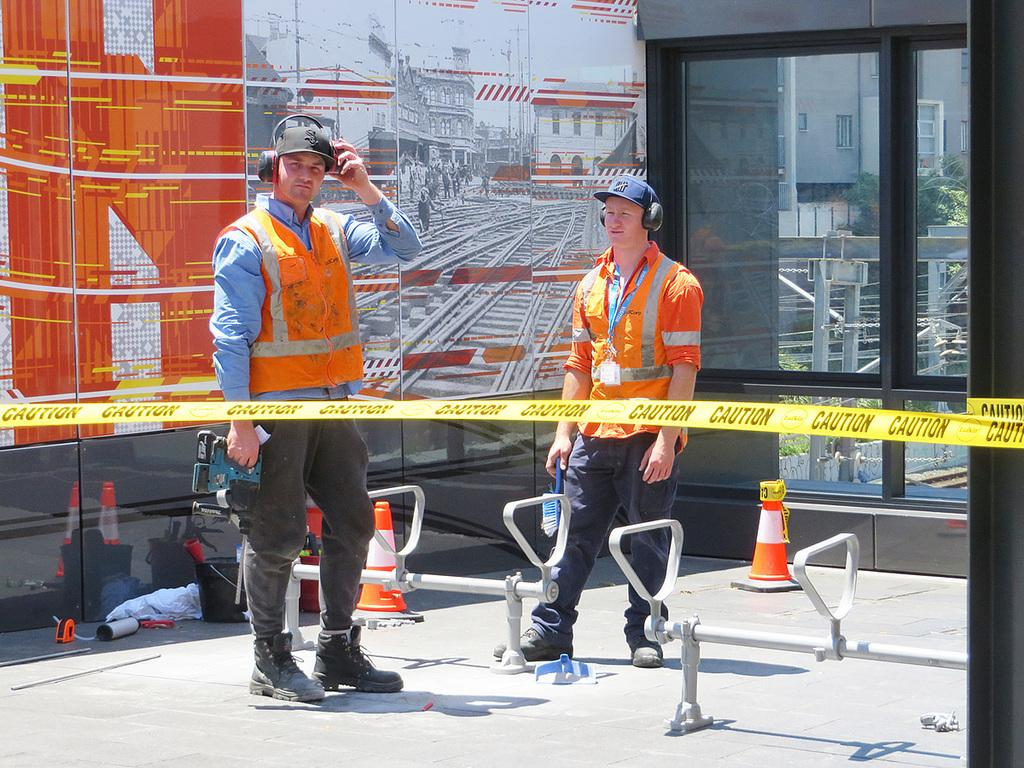How many people are in the image? There are two people in the image. What objects are present in the image? Traffic cones, a headset, and various other objects are visible in the image. What type of wall is in the image? There is a glass wall in the image. What can be seen on the glass wall? People, a train track, additional buildings, and more objects are visible on the glass wall. Is there a tent visible in the image? No, there is no tent present in the image. Can you see any worms crawling on the glass wall? No, there are no worms visible in the image. 